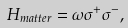Convert formula to latex. <formula><loc_0><loc_0><loc_500><loc_500>H _ { m a t t e r } = \omega \sigma ^ { + } \sigma ^ { - } ,</formula> 